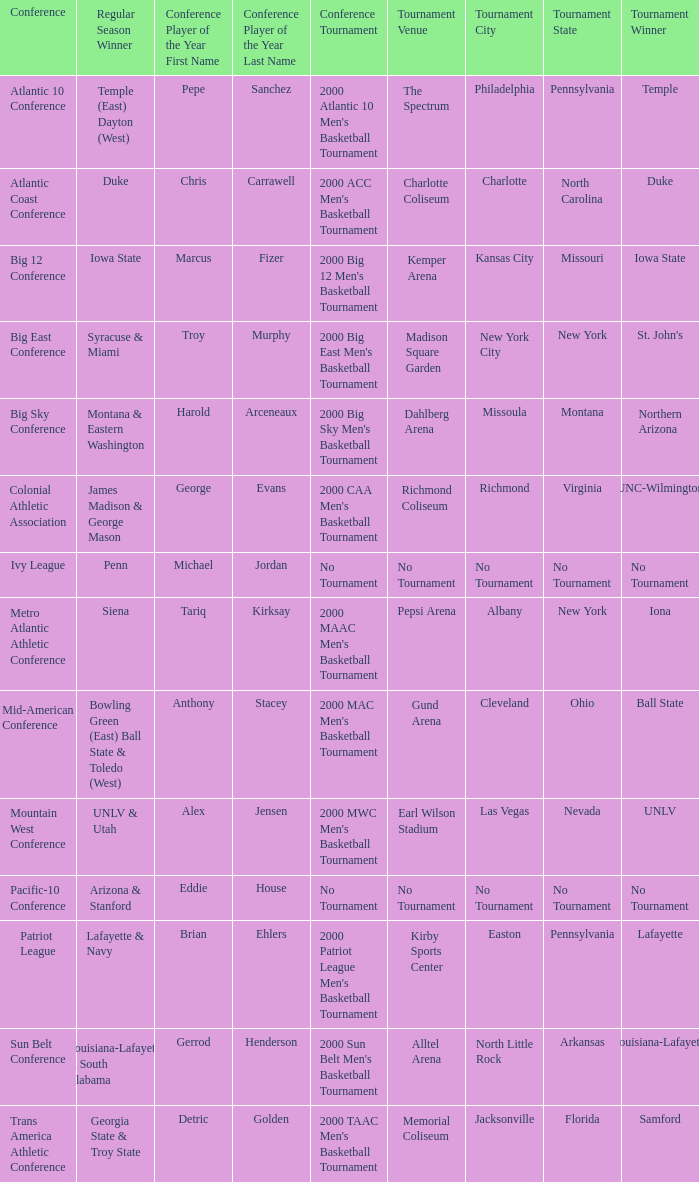Where did the ivy league conference competition take place? No Tournament. 